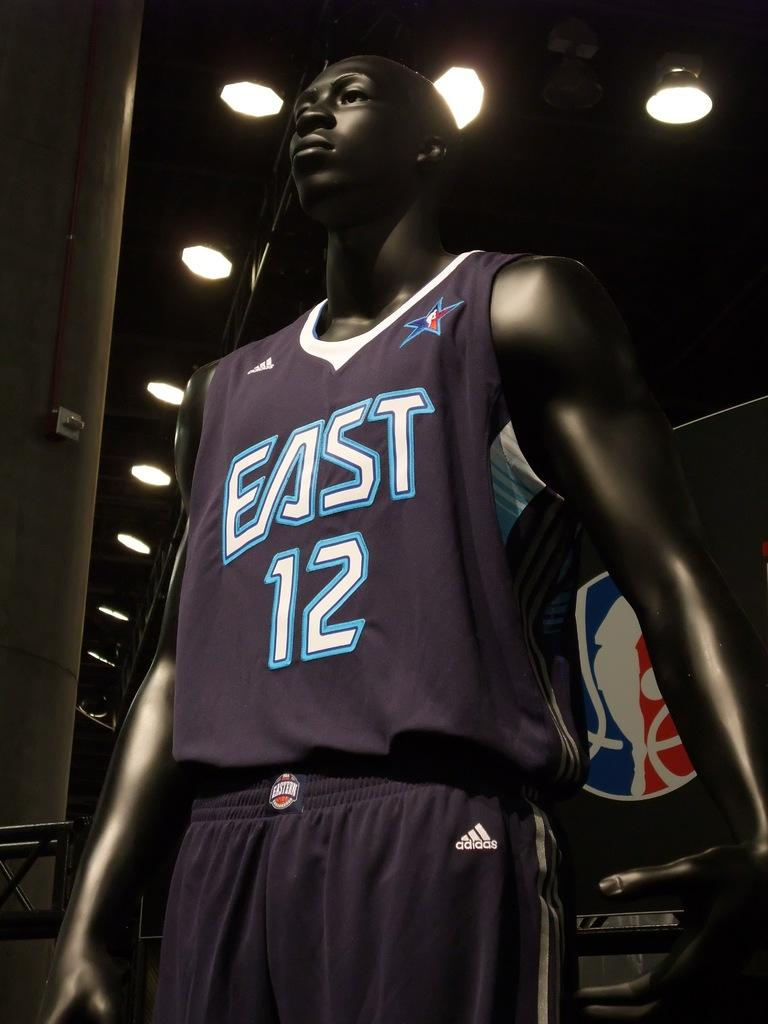Provide a one-sentence caption for the provided image. A mannequin models athletic clothing labelled for a team called East. 